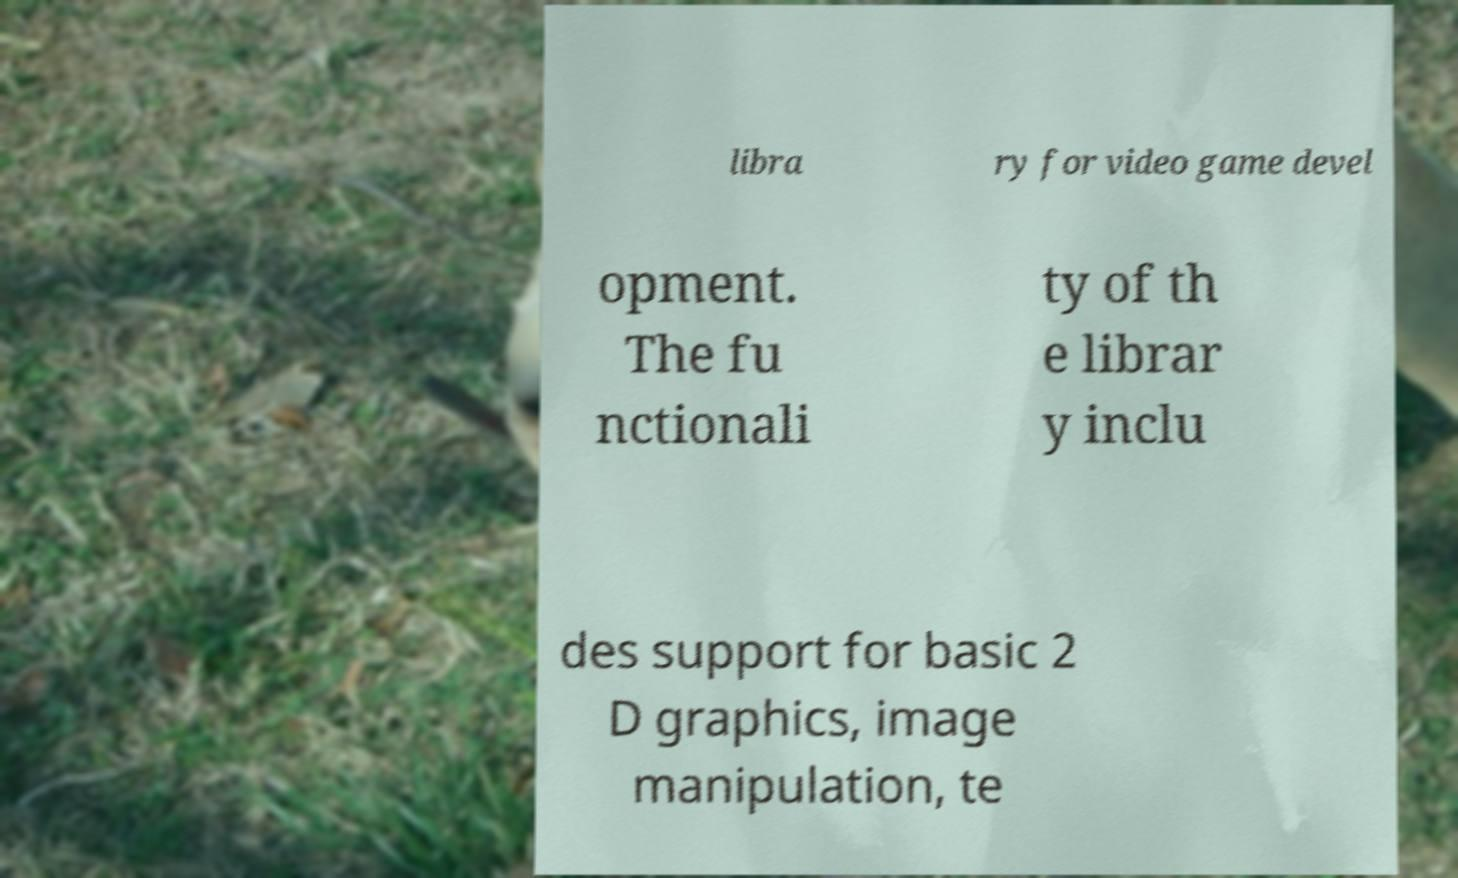I need the written content from this picture converted into text. Can you do that? libra ry for video game devel opment. The fu nctionali ty of th e librar y inclu des support for basic 2 D graphics, image manipulation, te 